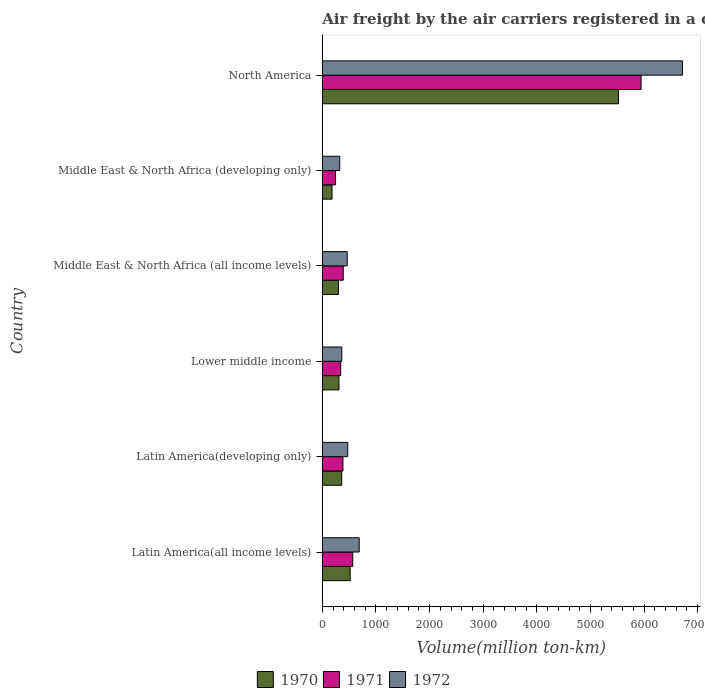How many groups of bars are there?
Give a very brief answer. 6. Are the number of bars per tick equal to the number of legend labels?
Provide a succinct answer. Yes. Are the number of bars on each tick of the Y-axis equal?
Offer a terse response. Yes. How many bars are there on the 3rd tick from the bottom?
Ensure brevity in your answer.  3. What is the label of the 6th group of bars from the top?
Offer a very short reply. Latin America(all income levels). What is the volume of the air carriers in 1972 in Middle East & North Africa (developing only)?
Make the answer very short. 324.6. Across all countries, what is the maximum volume of the air carriers in 1970?
Offer a very short reply. 5522.1. Across all countries, what is the minimum volume of the air carriers in 1972?
Keep it short and to the point. 324.6. In which country was the volume of the air carriers in 1971 maximum?
Make the answer very short. North America. In which country was the volume of the air carriers in 1971 minimum?
Provide a succinct answer. Middle East & North Africa (developing only). What is the total volume of the air carriers in 1972 in the graph?
Your answer should be very brief. 9029.3. What is the difference between the volume of the air carriers in 1970 in Latin America(developing only) and that in Middle East & North Africa (developing only)?
Give a very brief answer. 181.1. What is the difference between the volume of the air carriers in 1972 in Latin America(all income levels) and the volume of the air carriers in 1970 in Latin America(developing only)?
Your answer should be compact. 325.4. What is the average volume of the air carriers in 1970 per country?
Keep it short and to the point. 1199.17. What is the difference between the volume of the air carriers in 1971 and volume of the air carriers in 1970 in Middle East & North Africa (all income levels)?
Provide a short and direct response. 89.6. What is the ratio of the volume of the air carriers in 1972 in Latin America(all income levels) to that in North America?
Your answer should be very brief. 0.1. Is the volume of the air carriers in 1972 in Middle East & North Africa (all income levels) less than that in North America?
Your answer should be compact. Yes. Is the difference between the volume of the air carriers in 1971 in Latin America(all income levels) and Middle East & North Africa (developing only) greater than the difference between the volume of the air carriers in 1970 in Latin America(all income levels) and Middle East & North Africa (developing only)?
Provide a short and direct response. No. What is the difference between the highest and the second highest volume of the air carriers in 1970?
Your response must be concise. 5002.5. What is the difference between the highest and the lowest volume of the air carriers in 1972?
Your response must be concise. 6391.8. In how many countries, is the volume of the air carriers in 1972 greater than the average volume of the air carriers in 1972 taken over all countries?
Make the answer very short. 1. How many countries are there in the graph?
Keep it short and to the point. 6. Does the graph contain grids?
Your answer should be compact. No. How many legend labels are there?
Provide a succinct answer. 3. What is the title of the graph?
Your answer should be very brief. Air freight by the air carriers registered in a country. Does "2007" appear as one of the legend labels in the graph?
Provide a succinct answer. No. What is the label or title of the X-axis?
Offer a terse response. Volume(million ton-km). What is the Volume(million ton-km) in 1970 in Latin America(all income levels)?
Keep it short and to the point. 519.6. What is the Volume(million ton-km) in 1971 in Latin America(all income levels)?
Offer a terse response. 567.6. What is the Volume(million ton-km) of 1972 in Latin America(all income levels)?
Your response must be concise. 687.4. What is the Volume(million ton-km) in 1970 in Latin America(developing only)?
Your answer should be very brief. 362. What is the Volume(million ton-km) of 1971 in Latin America(developing only)?
Keep it short and to the point. 384. What is the Volume(million ton-km) of 1972 in Latin America(developing only)?
Offer a very short reply. 474.1. What is the Volume(million ton-km) in 1970 in Lower middle income?
Give a very brief answer. 310. What is the Volume(million ton-km) in 1971 in Lower middle income?
Make the answer very short. 342.7. What is the Volume(million ton-km) in 1972 in Lower middle income?
Make the answer very short. 363. What is the Volume(million ton-km) in 1970 in Middle East & North Africa (all income levels)?
Offer a very short reply. 300.4. What is the Volume(million ton-km) of 1971 in Middle East & North Africa (all income levels)?
Ensure brevity in your answer.  390. What is the Volume(million ton-km) of 1972 in Middle East & North Africa (all income levels)?
Provide a short and direct response. 463.8. What is the Volume(million ton-km) of 1970 in Middle East & North Africa (developing only)?
Your answer should be very brief. 180.9. What is the Volume(million ton-km) in 1971 in Middle East & North Africa (developing only)?
Provide a succinct answer. 246.2. What is the Volume(million ton-km) of 1972 in Middle East & North Africa (developing only)?
Offer a very short reply. 324.6. What is the Volume(million ton-km) in 1970 in North America?
Your response must be concise. 5522.1. What is the Volume(million ton-km) in 1971 in North America?
Your response must be concise. 5944.3. What is the Volume(million ton-km) of 1972 in North America?
Your answer should be very brief. 6716.4. Across all countries, what is the maximum Volume(million ton-km) in 1970?
Provide a succinct answer. 5522.1. Across all countries, what is the maximum Volume(million ton-km) of 1971?
Ensure brevity in your answer.  5944.3. Across all countries, what is the maximum Volume(million ton-km) in 1972?
Your answer should be compact. 6716.4. Across all countries, what is the minimum Volume(million ton-km) in 1970?
Offer a terse response. 180.9. Across all countries, what is the minimum Volume(million ton-km) of 1971?
Make the answer very short. 246.2. Across all countries, what is the minimum Volume(million ton-km) of 1972?
Offer a very short reply. 324.6. What is the total Volume(million ton-km) of 1970 in the graph?
Your answer should be very brief. 7195. What is the total Volume(million ton-km) in 1971 in the graph?
Your answer should be very brief. 7874.8. What is the total Volume(million ton-km) of 1972 in the graph?
Your response must be concise. 9029.3. What is the difference between the Volume(million ton-km) in 1970 in Latin America(all income levels) and that in Latin America(developing only)?
Make the answer very short. 157.6. What is the difference between the Volume(million ton-km) in 1971 in Latin America(all income levels) and that in Latin America(developing only)?
Your response must be concise. 183.6. What is the difference between the Volume(million ton-km) in 1972 in Latin America(all income levels) and that in Latin America(developing only)?
Offer a very short reply. 213.3. What is the difference between the Volume(million ton-km) in 1970 in Latin America(all income levels) and that in Lower middle income?
Make the answer very short. 209.6. What is the difference between the Volume(million ton-km) of 1971 in Latin America(all income levels) and that in Lower middle income?
Provide a short and direct response. 224.9. What is the difference between the Volume(million ton-km) in 1972 in Latin America(all income levels) and that in Lower middle income?
Keep it short and to the point. 324.4. What is the difference between the Volume(million ton-km) in 1970 in Latin America(all income levels) and that in Middle East & North Africa (all income levels)?
Your answer should be compact. 219.2. What is the difference between the Volume(million ton-km) in 1971 in Latin America(all income levels) and that in Middle East & North Africa (all income levels)?
Offer a terse response. 177.6. What is the difference between the Volume(million ton-km) in 1972 in Latin America(all income levels) and that in Middle East & North Africa (all income levels)?
Give a very brief answer. 223.6. What is the difference between the Volume(million ton-km) of 1970 in Latin America(all income levels) and that in Middle East & North Africa (developing only)?
Your answer should be very brief. 338.7. What is the difference between the Volume(million ton-km) in 1971 in Latin America(all income levels) and that in Middle East & North Africa (developing only)?
Offer a terse response. 321.4. What is the difference between the Volume(million ton-km) of 1972 in Latin America(all income levels) and that in Middle East & North Africa (developing only)?
Keep it short and to the point. 362.8. What is the difference between the Volume(million ton-km) of 1970 in Latin America(all income levels) and that in North America?
Provide a short and direct response. -5002.5. What is the difference between the Volume(million ton-km) of 1971 in Latin America(all income levels) and that in North America?
Your answer should be compact. -5376.7. What is the difference between the Volume(million ton-km) in 1972 in Latin America(all income levels) and that in North America?
Provide a succinct answer. -6029. What is the difference between the Volume(million ton-km) in 1971 in Latin America(developing only) and that in Lower middle income?
Provide a short and direct response. 41.3. What is the difference between the Volume(million ton-km) of 1972 in Latin America(developing only) and that in Lower middle income?
Ensure brevity in your answer.  111.1. What is the difference between the Volume(million ton-km) of 1970 in Latin America(developing only) and that in Middle East & North Africa (all income levels)?
Give a very brief answer. 61.6. What is the difference between the Volume(million ton-km) of 1971 in Latin America(developing only) and that in Middle East & North Africa (all income levels)?
Provide a short and direct response. -6. What is the difference between the Volume(million ton-km) in 1972 in Latin America(developing only) and that in Middle East & North Africa (all income levels)?
Provide a short and direct response. 10.3. What is the difference between the Volume(million ton-km) in 1970 in Latin America(developing only) and that in Middle East & North Africa (developing only)?
Your answer should be very brief. 181.1. What is the difference between the Volume(million ton-km) in 1971 in Latin America(developing only) and that in Middle East & North Africa (developing only)?
Give a very brief answer. 137.8. What is the difference between the Volume(million ton-km) of 1972 in Latin America(developing only) and that in Middle East & North Africa (developing only)?
Your response must be concise. 149.5. What is the difference between the Volume(million ton-km) in 1970 in Latin America(developing only) and that in North America?
Provide a succinct answer. -5160.1. What is the difference between the Volume(million ton-km) in 1971 in Latin America(developing only) and that in North America?
Offer a terse response. -5560.3. What is the difference between the Volume(million ton-km) in 1972 in Latin America(developing only) and that in North America?
Give a very brief answer. -6242.3. What is the difference between the Volume(million ton-km) in 1970 in Lower middle income and that in Middle East & North Africa (all income levels)?
Your answer should be very brief. 9.6. What is the difference between the Volume(million ton-km) in 1971 in Lower middle income and that in Middle East & North Africa (all income levels)?
Give a very brief answer. -47.3. What is the difference between the Volume(million ton-km) in 1972 in Lower middle income and that in Middle East & North Africa (all income levels)?
Give a very brief answer. -100.8. What is the difference between the Volume(million ton-km) in 1970 in Lower middle income and that in Middle East & North Africa (developing only)?
Keep it short and to the point. 129.1. What is the difference between the Volume(million ton-km) in 1971 in Lower middle income and that in Middle East & North Africa (developing only)?
Provide a succinct answer. 96.5. What is the difference between the Volume(million ton-km) of 1972 in Lower middle income and that in Middle East & North Africa (developing only)?
Your response must be concise. 38.4. What is the difference between the Volume(million ton-km) of 1970 in Lower middle income and that in North America?
Make the answer very short. -5212.1. What is the difference between the Volume(million ton-km) in 1971 in Lower middle income and that in North America?
Provide a short and direct response. -5601.6. What is the difference between the Volume(million ton-km) of 1972 in Lower middle income and that in North America?
Provide a succinct answer. -6353.4. What is the difference between the Volume(million ton-km) in 1970 in Middle East & North Africa (all income levels) and that in Middle East & North Africa (developing only)?
Offer a very short reply. 119.5. What is the difference between the Volume(million ton-km) in 1971 in Middle East & North Africa (all income levels) and that in Middle East & North Africa (developing only)?
Offer a very short reply. 143.8. What is the difference between the Volume(million ton-km) of 1972 in Middle East & North Africa (all income levels) and that in Middle East & North Africa (developing only)?
Provide a succinct answer. 139.2. What is the difference between the Volume(million ton-km) of 1970 in Middle East & North Africa (all income levels) and that in North America?
Make the answer very short. -5221.7. What is the difference between the Volume(million ton-km) in 1971 in Middle East & North Africa (all income levels) and that in North America?
Offer a very short reply. -5554.3. What is the difference between the Volume(million ton-km) in 1972 in Middle East & North Africa (all income levels) and that in North America?
Your answer should be very brief. -6252.6. What is the difference between the Volume(million ton-km) of 1970 in Middle East & North Africa (developing only) and that in North America?
Provide a short and direct response. -5341.2. What is the difference between the Volume(million ton-km) of 1971 in Middle East & North Africa (developing only) and that in North America?
Provide a succinct answer. -5698.1. What is the difference between the Volume(million ton-km) of 1972 in Middle East & North Africa (developing only) and that in North America?
Offer a very short reply. -6391.8. What is the difference between the Volume(million ton-km) in 1970 in Latin America(all income levels) and the Volume(million ton-km) in 1971 in Latin America(developing only)?
Provide a short and direct response. 135.6. What is the difference between the Volume(million ton-km) in 1970 in Latin America(all income levels) and the Volume(million ton-km) in 1972 in Latin America(developing only)?
Give a very brief answer. 45.5. What is the difference between the Volume(million ton-km) in 1971 in Latin America(all income levels) and the Volume(million ton-km) in 1972 in Latin America(developing only)?
Provide a succinct answer. 93.5. What is the difference between the Volume(million ton-km) of 1970 in Latin America(all income levels) and the Volume(million ton-km) of 1971 in Lower middle income?
Your answer should be compact. 176.9. What is the difference between the Volume(million ton-km) in 1970 in Latin America(all income levels) and the Volume(million ton-km) in 1972 in Lower middle income?
Offer a very short reply. 156.6. What is the difference between the Volume(million ton-km) in 1971 in Latin America(all income levels) and the Volume(million ton-km) in 1972 in Lower middle income?
Offer a terse response. 204.6. What is the difference between the Volume(million ton-km) in 1970 in Latin America(all income levels) and the Volume(million ton-km) in 1971 in Middle East & North Africa (all income levels)?
Give a very brief answer. 129.6. What is the difference between the Volume(million ton-km) in 1970 in Latin America(all income levels) and the Volume(million ton-km) in 1972 in Middle East & North Africa (all income levels)?
Provide a short and direct response. 55.8. What is the difference between the Volume(million ton-km) in 1971 in Latin America(all income levels) and the Volume(million ton-km) in 1972 in Middle East & North Africa (all income levels)?
Provide a short and direct response. 103.8. What is the difference between the Volume(million ton-km) in 1970 in Latin America(all income levels) and the Volume(million ton-km) in 1971 in Middle East & North Africa (developing only)?
Your answer should be compact. 273.4. What is the difference between the Volume(million ton-km) of 1970 in Latin America(all income levels) and the Volume(million ton-km) of 1972 in Middle East & North Africa (developing only)?
Provide a succinct answer. 195. What is the difference between the Volume(million ton-km) in 1971 in Latin America(all income levels) and the Volume(million ton-km) in 1972 in Middle East & North Africa (developing only)?
Offer a terse response. 243. What is the difference between the Volume(million ton-km) in 1970 in Latin America(all income levels) and the Volume(million ton-km) in 1971 in North America?
Provide a short and direct response. -5424.7. What is the difference between the Volume(million ton-km) of 1970 in Latin America(all income levels) and the Volume(million ton-km) of 1972 in North America?
Ensure brevity in your answer.  -6196.8. What is the difference between the Volume(million ton-km) of 1971 in Latin America(all income levels) and the Volume(million ton-km) of 1972 in North America?
Offer a terse response. -6148.8. What is the difference between the Volume(million ton-km) in 1970 in Latin America(developing only) and the Volume(million ton-km) in 1971 in Lower middle income?
Give a very brief answer. 19.3. What is the difference between the Volume(million ton-km) of 1971 in Latin America(developing only) and the Volume(million ton-km) of 1972 in Lower middle income?
Ensure brevity in your answer.  21. What is the difference between the Volume(million ton-km) in 1970 in Latin America(developing only) and the Volume(million ton-km) in 1972 in Middle East & North Africa (all income levels)?
Keep it short and to the point. -101.8. What is the difference between the Volume(million ton-km) in 1971 in Latin America(developing only) and the Volume(million ton-km) in 1972 in Middle East & North Africa (all income levels)?
Give a very brief answer. -79.8. What is the difference between the Volume(million ton-km) of 1970 in Latin America(developing only) and the Volume(million ton-km) of 1971 in Middle East & North Africa (developing only)?
Make the answer very short. 115.8. What is the difference between the Volume(million ton-km) of 1970 in Latin America(developing only) and the Volume(million ton-km) of 1972 in Middle East & North Africa (developing only)?
Offer a terse response. 37.4. What is the difference between the Volume(million ton-km) of 1971 in Latin America(developing only) and the Volume(million ton-km) of 1972 in Middle East & North Africa (developing only)?
Offer a very short reply. 59.4. What is the difference between the Volume(million ton-km) in 1970 in Latin America(developing only) and the Volume(million ton-km) in 1971 in North America?
Make the answer very short. -5582.3. What is the difference between the Volume(million ton-km) in 1970 in Latin America(developing only) and the Volume(million ton-km) in 1972 in North America?
Ensure brevity in your answer.  -6354.4. What is the difference between the Volume(million ton-km) in 1971 in Latin America(developing only) and the Volume(million ton-km) in 1972 in North America?
Ensure brevity in your answer.  -6332.4. What is the difference between the Volume(million ton-km) of 1970 in Lower middle income and the Volume(million ton-km) of 1971 in Middle East & North Africa (all income levels)?
Give a very brief answer. -80. What is the difference between the Volume(million ton-km) in 1970 in Lower middle income and the Volume(million ton-km) in 1972 in Middle East & North Africa (all income levels)?
Make the answer very short. -153.8. What is the difference between the Volume(million ton-km) in 1971 in Lower middle income and the Volume(million ton-km) in 1972 in Middle East & North Africa (all income levels)?
Your answer should be compact. -121.1. What is the difference between the Volume(million ton-km) of 1970 in Lower middle income and the Volume(million ton-km) of 1971 in Middle East & North Africa (developing only)?
Keep it short and to the point. 63.8. What is the difference between the Volume(million ton-km) of 1970 in Lower middle income and the Volume(million ton-km) of 1972 in Middle East & North Africa (developing only)?
Offer a very short reply. -14.6. What is the difference between the Volume(million ton-km) of 1970 in Lower middle income and the Volume(million ton-km) of 1971 in North America?
Keep it short and to the point. -5634.3. What is the difference between the Volume(million ton-km) of 1970 in Lower middle income and the Volume(million ton-km) of 1972 in North America?
Make the answer very short. -6406.4. What is the difference between the Volume(million ton-km) of 1971 in Lower middle income and the Volume(million ton-km) of 1972 in North America?
Your response must be concise. -6373.7. What is the difference between the Volume(million ton-km) of 1970 in Middle East & North Africa (all income levels) and the Volume(million ton-km) of 1971 in Middle East & North Africa (developing only)?
Your answer should be very brief. 54.2. What is the difference between the Volume(million ton-km) of 1970 in Middle East & North Africa (all income levels) and the Volume(million ton-km) of 1972 in Middle East & North Africa (developing only)?
Keep it short and to the point. -24.2. What is the difference between the Volume(million ton-km) of 1971 in Middle East & North Africa (all income levels) and the Volume(million ton-km) of 1972 in Middle East & North Africa (developing only)?
Your answer should be compact. 65.4. What is the difference between the Volume(million ton-km) in 1970 in Middle East & North Africa (all income levels) and the Volume(million ton-km) in 1971 in North America?
Your answer should be very brief. -5643.9. What is the difference between the Volume(million ton-km) of 1970 in Middle East & North Africa (all income levels) and the Volume(million ton-km) of 1972 in North America?
Provide a short and direct response. -6416. What is the difference between the Volume(million ton-km) of 1971 in Middle East & North Africa (all income levels) and the Volume(million ton-km) of 1972 in North America?
Ensure brevity in your answer.  -6326.4. What is the difference between the Volume(million ton-km) of 1970 in Middle East & North Africa (developing only) and the Volume(million ton-km) of 1971 in North America?
Provide a succinct answer. -5763.4. What is the difference between the Volume(million ton-km) of 1970 in Middle East & North Africa (developing only) and the Volume(million ton-km) of 1972 in North America?
Keep it short and to the point. -6535.5. What is the difference between the Volume(million ton-km) of 1971 in Middle East & North Africa (developing only) and the Volume(million ton-km) of 1972 in North America?
Your answer should be compact. -6470.2. What is the average Volume(million ton-km) in 1970 per country?
Offer a terse response. 1199.17. What is the average Volume(million ton-km) in 1971 per country?
Your answer should be very brief. 1312.47. What is the average Volume(million ton-km) of 1972 per country?
Provide a succinct answer. 1504.88. What is the difference between the Volume(million ton-km) in 1970 and Volume(million ton-km) in 1971 in Latin America(all income levels)?
Provide a succinct answer. -48. What is the difference between the Volume(million ton-km) in 1970 and Volume(million ton-km) in 1972 in Latin America(all income levels)?
Offer a very short reply. -167.8. What is the difference between the Volume(million ton-km) of 1971 and Volume(million ton-km) of 1972 in Latin America(all income levels)?
Give a very brief answer. -119.8. What is the difference between the Volume(million ton-km) of 1970 and Volume(million ton-km) of 1971 in Latin America(developing only)?
Your answer should be very brief. -22. What is the difference between the Volume(million ton-km) in 1970 and Volume(million ton-km) in 1972 in Latin America(developing only)?
Provide a succinct answer. -112.1. What is the difference between the Volume(million ton-km) of 1971 and Volume(million ton-km) of 1972 in Latin America(developing only)?
Your response must be concise. -90.1. What is the difference between the Volume(million ton-km) of 1970 and Volume(million ton-km) of 1971 in Lower middle income?
Offer a very short reply. -32.7. What is the difference between the Volume(million ton-km) in 1970 and Volume(million ton-km) in 1972 in Lower middle income?
Your answer should be compact. -53. What is the difference between the Volume(million ton-km) of 1971 and Volume(million ton-km) of 1972 in Lower middle income?
Offer a terse response. -20.3. What is the difference between the Volume(million ton-km) of 1970 and Volume(million ton-km) of 1971 in Middle East & North Africa (all income levels)?
Your answer should be very brief. -89.6. What is the difference between the Volume(million ton-km) in 1970 and Volume(million ton-km) in 1972 in Middle East & North Africa (all income levels)?
Give a very brief answer. -163.4. What is the difference between the Volume(million ton-km) of 1971 and Volume(million ton-km) of 1972 in Middle East & North Africa (all income levels)?
Offer a terse response. -73.8. What is the difference between the Volume(million ton-km) of 1970 and Volume(million ton-km) of 1971 in Middle East & North Africa (developing only)?
Your response must be concise. -65.3. What is the difference between the Volume(million ton-km) in 1970 and Volume(million ton-km) in 1972 in Middle East & North Africa (developing only)?
Give a very brief answer. -143.7. What is the difference between the Volume(million ton-km) in 1971 and Volume(million ton-km) in 1972 in Middle East & North Africa (developing only)?
Offer a very short reply. -78.4. What is the difference between the Volume(million ton-km) of 1970 and Volume(million ton-km) of 1971 in North America?
Keep it short and to the point. -422.2. What is the difference between the Volume(million ton-km) of 1970 and Volume(million ton-km) of 1972 in North America?
Ensure brevity in your answer.  -1194.3. What is the difference between the Volume(million ton-km) in 1971 and Volume(million ton-km) in 1972 in North America?
Provide a short and direct response. -772.1. What is the ratio of the Volume(million ton-km) in 1970 in Latin America(all income levels) to that in Latin America(developing only)?
Provide a succinct answer. 1.44. What is the ratio of the Volume(million ton-km) of 1971 in Latin America(all income levels) to that in Latin America(developing only)?
Provide a succinct answer. 1.48. What is the ratio of the Volume(million ton-km) in 1972 in Latin America(all income levels) to that in Latin America(developing only)?
Your answer should be compact. 1.45. What is the ratio of the Volume(million ton-km) in 1970 in Latin America(all income levels) to that in Lower middle income?
Your answer should be very brief. 1.68. What is the ratio of the Volume(million ton-km) of 1971 in Latin America(all income levels) to that in Lower middle income?
Your answer should be compact. 1.66. What is the ratio of the Volume(million ton-km) in 1972 in Latin America(all income levels) to that in Lower middle income?
Your answer should be compact. 1.89. What is the ratio of the Volume(million ton-km) of 1970 in Latin America(all income levels) to that in Middle East & North Africa (all income levels)?
Your answer should be compact. 1.73. What is the ratio of the Volume(million ton-km) of 1971 in Latin America(all income levels) to that in Middle East & North Africa (all income levels)?
Offer a terse response. 1.46. What is the ratio of the Volume(million ton-km) in 1972 in Latin America(all income levels) to that in Middle East & North Africa (all income levels)?
Your answer should be compact. 1.48. What is the ratio of the Volume(million ton-km) in 1970 in Latin America(all income levels) to that in Middle East & North Africa (developing only)?
Ensure brevity in your answer.  2.87. What is the ratio of the Volume(million ton-km) in 1971 in Latin America(all income levels) to that in Middle East & North Africa (developing only)?
Your answer should be compact. 2.31. What is the ratio of the Volume(million ton-km) of 1972 in Latin America(all income levels) to that in Middle East & North Africa (developing only)?
Offer a terse response. 2.12. What is the ratio of the Volume(million ton-km) of 1970 in Latin America(all income levels) to that in North America?
Your answer should be compact. 0.09. What is the ratio of the Volume(million ton-km) of 1971 in Latin America(all income levels) to that in North America?
Provide a succinct answer. 0.1. What is the ratio of the Volume(million ton-km) of 1972 in Latin America(all income levels) to that in North America?
Offer a terse response. 0.1. What is the ratio of the Volume(million ton-km) of 1970 in Latin America(developing only) to that in Lower middle income?
Your answer should be compact. 1.17. What is the ratio of the Volume(million ton-km) in 1971 in Latin America(developing only) to that in Lower middle income?
Your answer should be compact. 1.12. What is the ratio of the Volume(million ton-km) of 1972 in Latin America(developing only) to that in Lower middle income?
Provide a short and direct response. 1.31. What is the ratio of the Volume(million ton-km) of 1970 in Latin America(developing only) to that in Middle East & North Africa (all income levels)?
Keep it short and to the point. 1.21. What is the ratio of the Volume(million ton-km) in 1971 in Latin America(developing only) to that in Middle East & North Africa (all income levels)?
Keep it short and to the point. 0.98. What is the ratio of the Volume(million ton-km) in 1972 in Latin America(developing only) to that in Middle East & North Africa (all income levels)?
Provide a succinct answer. 1.02. What is the ratio of the Volume(million ton-km) in 1970 in Latin America(developing only) to that in Middle East & North Africa (developing only)?
Provide a short and direct response. 2. What is the ratio of the Volume(million ton-km) of 1971 in Latin America(developing only) to that in Middle East & North Africa (developing only)?
Offer a very short reply. 1.56. What is the ratio of the Volume(million ton-km) in 1972 in Latin America(developing only) to that in Middle East & North Africa (developing only)?
Your response must be concise. 1.46. What is the ratio of the Volume(million ton-km) in 1970 in Latin America(developing only) to that in North America?
Provide a short and direct response. 0.07. What is the ratio of the Volume(million ton-km) of 1971 in Latin America(developing only) to that in North America?
Your answer should be very brief. 0.06. What is the ratio of the Volume(million ton-km) of 1972 in Latin America(developing only) to that in North America?
Offer a very short reply. 0.07. What is the ratio of the Volume(million ton-km) in 1970 in Lower middle income to that in Middle East & North Africa (all income levels)?
Provide a succinct answer. 1.03. What is the ratio of the Volume(million ton-km) in 1971 in Lower middle income to that in Middle East & North Africa (all income levels)?
Give a very brief answer. 0.88. What is the ratio of the Volume(million ton-km) of 1972 in Lower middle income to that in Middle East & North Africa (all income levels)?
Your response must be concise. 0.78. What is the ratio of the Volume(million ton-km) in 1970 in Lower middle income to that in Middle East & North Africa (developing only)?
Keep it short and to the point. 1.71. What is the ratio of the Volume(million ton-km) in 1971 in Lower middle income to that in Middle East & North Africa (developing only)?
Offer a terse response. 1.39. What is the ratio of the Volume(million ton-km) of 1972 in Lower middle income to that in Middle East & North Africa (developing only)?
Give a very brief answer. 1.12. What is the ratio of the Volume(million ton-km) of 1970 in Lower middle income to that in North America?
Provide a short and direct response. 0.06. What is the ratio of the Volume(million ton-km) in 1971 in Lower middle income to that in North America?
Offer a very short reply. 0.06. What is the ratio of the Volume(million ton-km) of 1972 in Lower middle income to that in North America?
Ensure brevity in your answer.  0.05. What is the ratio of the Volume(million ton-km) of 1970 in Middle East & North Africa (all income levels) to that in Middle East & North Africa (developing only)?
Offer a very short reply. 1.66. What is the ratio of the Volume(million ton-km) in 1971 in Middle East & North Africa (all income levels) to that in Middle East & North Africa (developing only)?
Provide a succinct answer. 1.58. What is the ratio of the Volume(million ton-km) in 1972 in Middle East & North Africa (all income levels) to that in Middle East & North Africa (developing only)?
Make the answer very short. 1.43. What is the ratio of the Volume(million ton-km) of 1970 in Middle East & North Africa (all income levels) to that in North America?
Your answer should be compact. 0.05. What is the ratio of the Volume(million ton-km) in 1971 in Middle East & North Africa (all income levels) to that in North America?
Your answer should be compact. 0.07. What is the ratio of the Volume(million ton-km) of 1972 in Middle East & North Africa (all income levels) to that in North America?
Offer a terse response. 0.07. What is the ratio of the Volume(million ton-km) in 1970 in Middle East & North Africa (developing only) to that in North America?
Give a very brief answer. 0.03. What is the ratio of the Volume(million ton-km) in 1971 in Middle East & North Africa (developing only) to that in North America?
Keep it short and to the point. 0.04. What is the ratio of the Volume(million ton-km) in 1972 in Middle East & North Africa (developing only) to that in North America?
Keep it short and to the point. 0.05. What is the difference between the highest and the second highest Volume(million ton-km) in 1970?
Ensure brevity in your answer.  5002.5. What is the difference between the highest and the second highest Volume(million ton-km) in 1971?
Offer a terse response. 5376.7. What is the difference between the highest and the second highest Volume(million ton-km) of 1972?
Keep it short and to the point. 6029. What is the difference between the highest and the lowest Volume(million ton-km) of 1970?
Keep it short and to the point. 5341.2. What is the difference between the highest and the lowest Volume(million ton-km) in 1971?
Provide a succinct answer. 5698.1. What is the difference between the highest and the lowest Volume(million ton-km) in 1972?
Provide a short and direct response. 6391.8. 